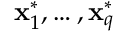Convert formula to latex. <formula><loc_0><loc_0><loc_500><loc_500>x _ { 1 } ^ { * } , \dots , x _ { q } ^ { * }</formula> 